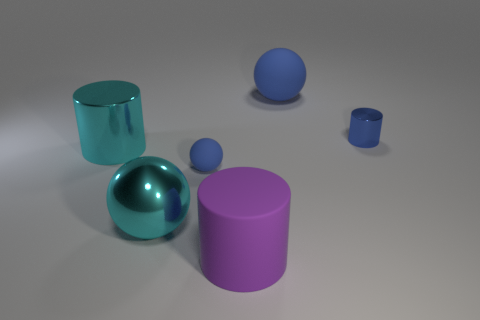There is another small thing that is the same color as the small matte object; what material is it?
Keep it short and to the point. Metal. Is there any other thing that has the same color as the big rubber sphere?
Your answer should be compact. Yes. There is a large matte object that is behind the tiny cylinder; is it the same color as the tiny metal cylinder?
Provide a short and direct response. Yes. What is the shape of the small rubber thing that is the same color as the tiny cylinder?
Provide a succinct answer. Sphere. Are there any shiny cylinders that have the same color as the big shiny ball?
Your answer should be compact. Yes. There is another matte ball that is the same color as the tiny sphere; what size is it?
Give a very brief answer. Large. There is a big metal sphere; is its color the same as the big cylinder that is behind the tiny ball?
Keep it short and to the point. Yes. What is the shape of the metallic thing on the left side of the large cyan sphere?
Provide a succinct answer. Cylinder. Are there more small cylinders behind the purple matte thing than large red cylinders?
Offer a very short reply. Yes. What number of big purple matte things are in front of the big sphere that is behind the matte sphere in front of the big cyan metal cylinder?
Make the answer very short. 1. 